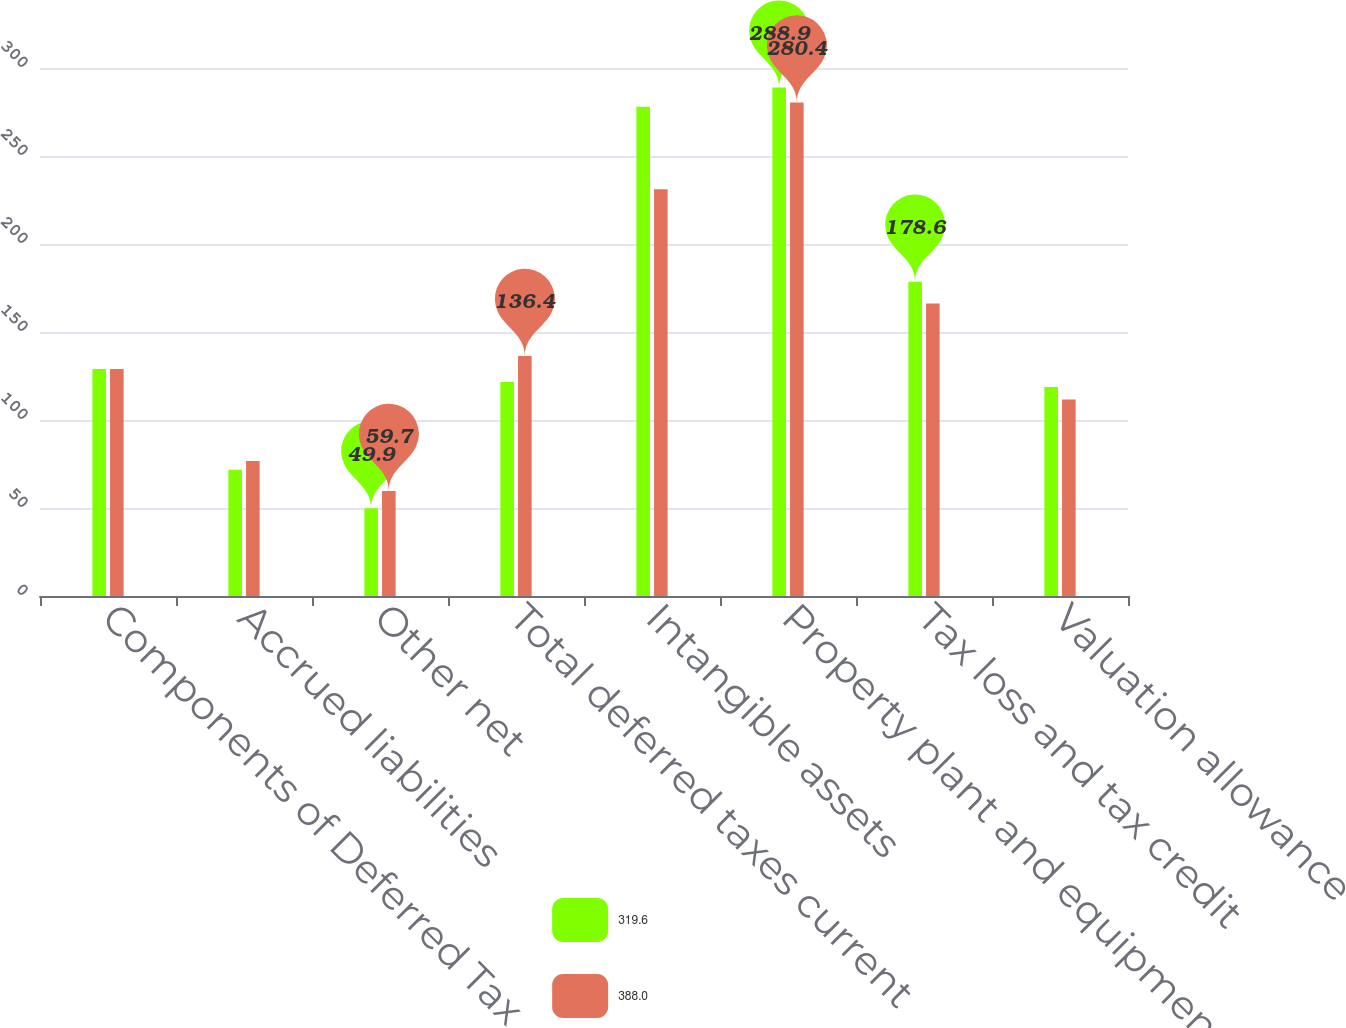Convert chart. <chart><loc_0><loc_0><loc_500><loc_500><stacked_bar_chart><ecel><fcel>Components of Deferred Tax<fcel>Accrued liabilities<fcel>Other net<fcel>Total deferred taxes current<fcel>Intangible assets<fcel>Property plant and equipment<fcel>Tax loss and tax credit<fcel>Valuation allowance<nl><fcel>319.6<fcel>129<fcel>71.7<fcel>49.9<fcel>121.6<fcel>278<fcel>288.9<fcel>178.6<fcel>118.8<nl><fcel>388<fcel>129<fcel>76.7<fcel>59.7<fcel>136.4<fcel>231.1<fcel>280.4<fcel>166.2<fcel>111.6<nl></chart> 